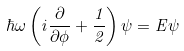<formula> <loc_0><loc_0><loc_500><loc_500>\hbar { \omega } \left ( { i \frac { \partial } { \partial \phi } + \frac { 1 } { 2 } } \right ) \psi = E \psi</formula> 